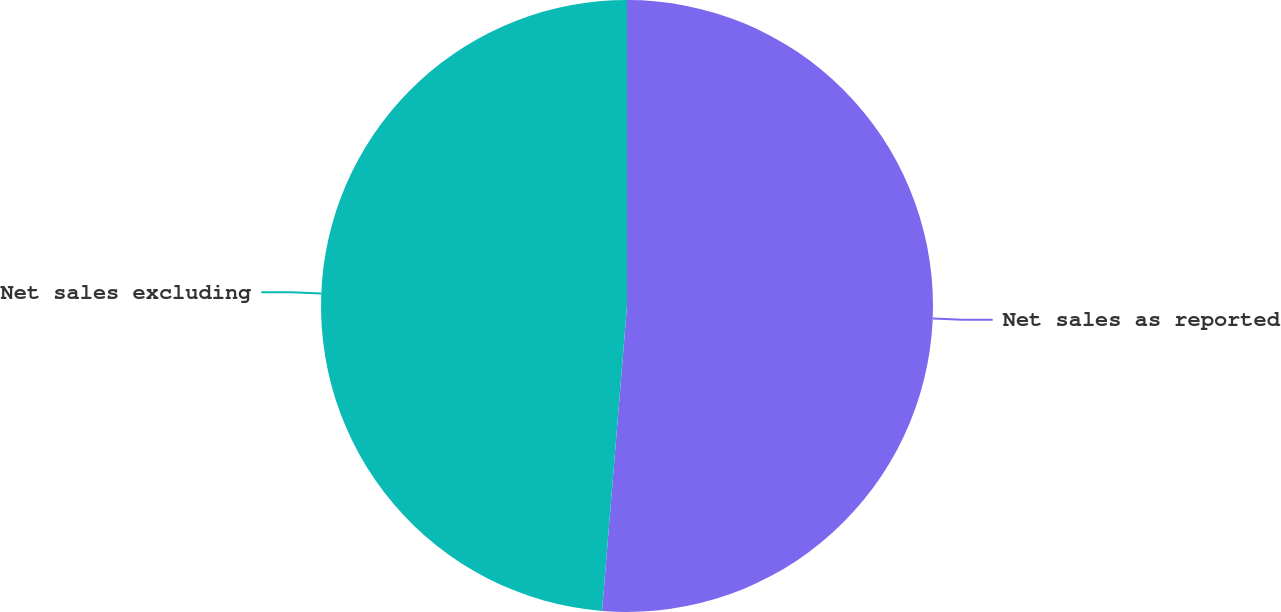<chart> <loc_0><loc_0><loc_500><loc_500><pie_chart><fcel>Net sales as reported<fcel>Net sales excluding<nl><fcel>51.3%<fcel>48.7%<nl></chart> 